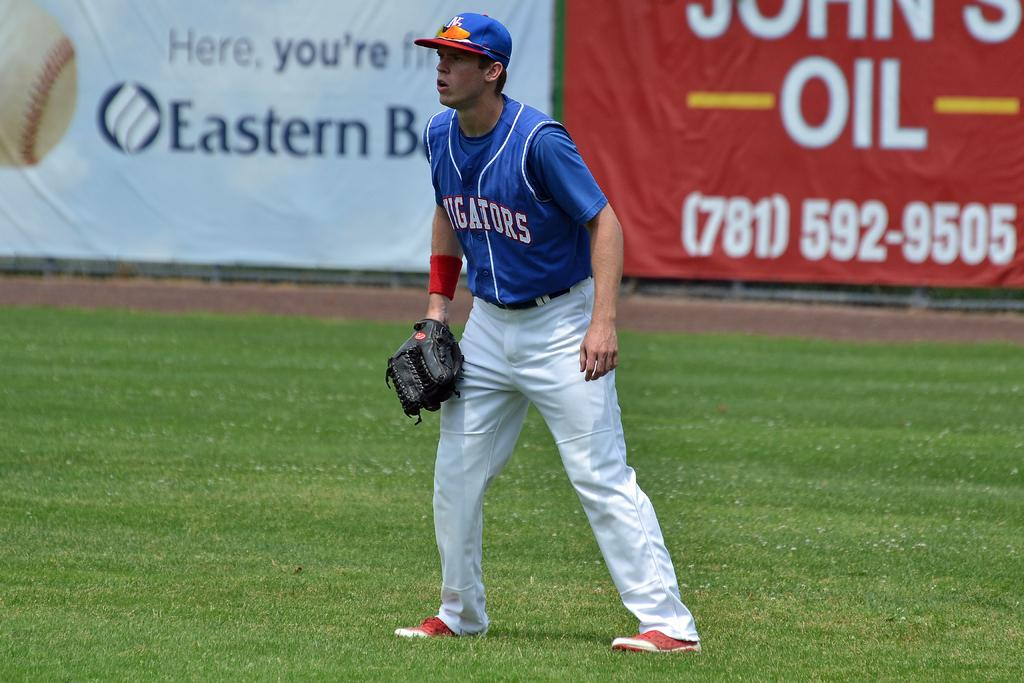<image>
Provide a brief description of the given image. A man playing baseball has "Aligators" on his jersey. 